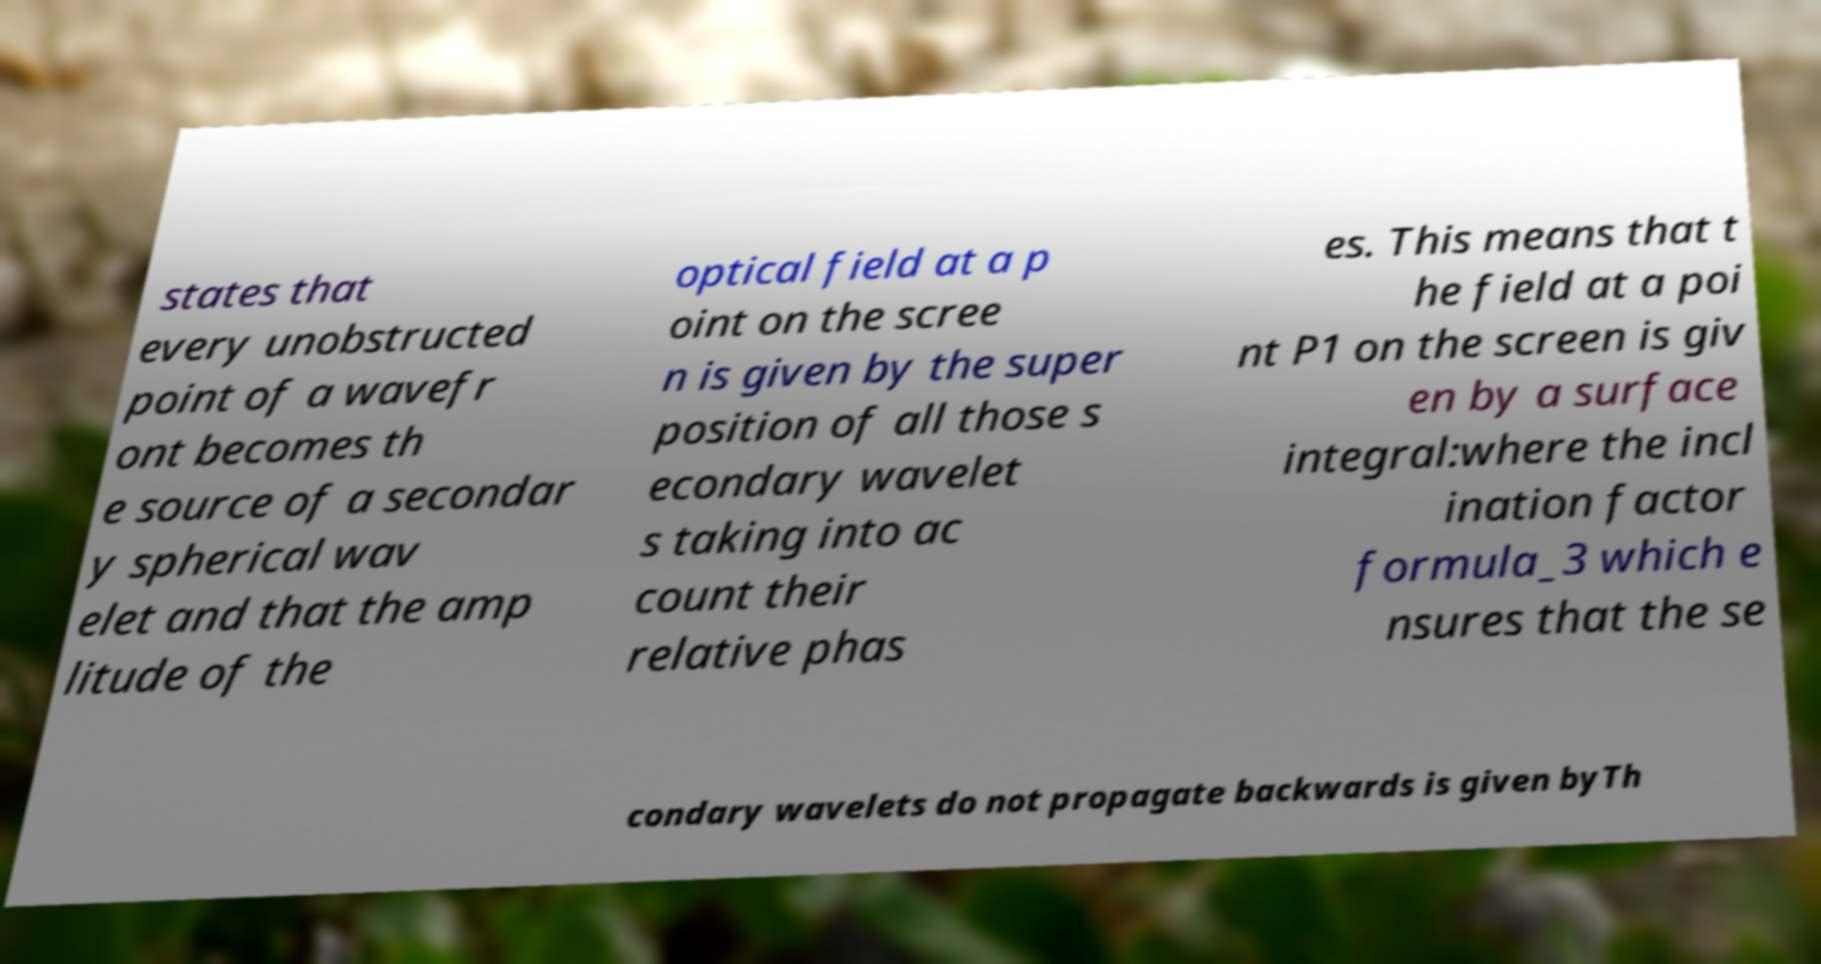Can you read and provide the text displayed in the image?This photo seems to have some interesting text. Can you extract and type it out for me? states that every unobstructed point of a wavefr ont becomes th e source of a secondar y spherical wav elet and that the amp litude of the optical field at a p oint on the scree n is given by the super position of all those s econdary wavelet s taking into ac count their relative phas es. This means that t he field at a poi nt P1 on the screen is giv en by a surface integral:where the incl ination factor formula_3 which e nsures that the se condary wavelets do not propagate backwards is given byTh 